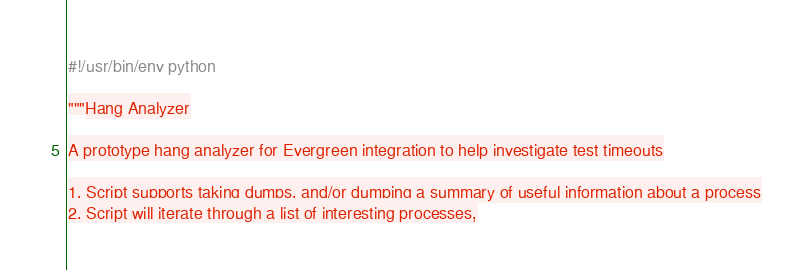Convert code to text. <code><loc_0><loc_0><loc_500><loc_500><_Python_>#!/usr/bin/env python

"""Hang Analyzer

A prototype hang analyzer for Evergreen integration to help investigate test timeouts

1. Script supports taking dumps, and/or dumping a summary of useful information about a process
2. Script will iterate through a list of interesting processes,</code> 